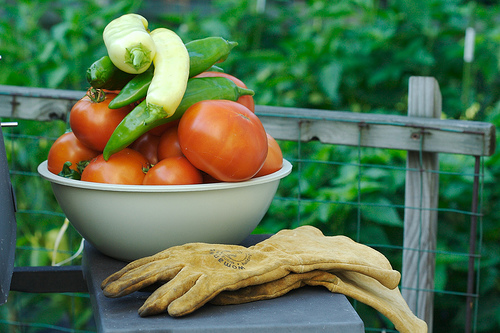<image>
Can you confirm if the fence is behind the tomato? Yes. From this viewpoint, the fence is positioned behind the tomato, with the tomato partially or fully occluding the fence. Is the gloves in front of the bowl? Yes. The gloves is positioned in front of the bowl, appearing closer to the camera viewpoint. Is there a bowl in front of the gloves? No. The bowl is not in front of the gloves. The spatial positioning shows a different relationship between these objects. 